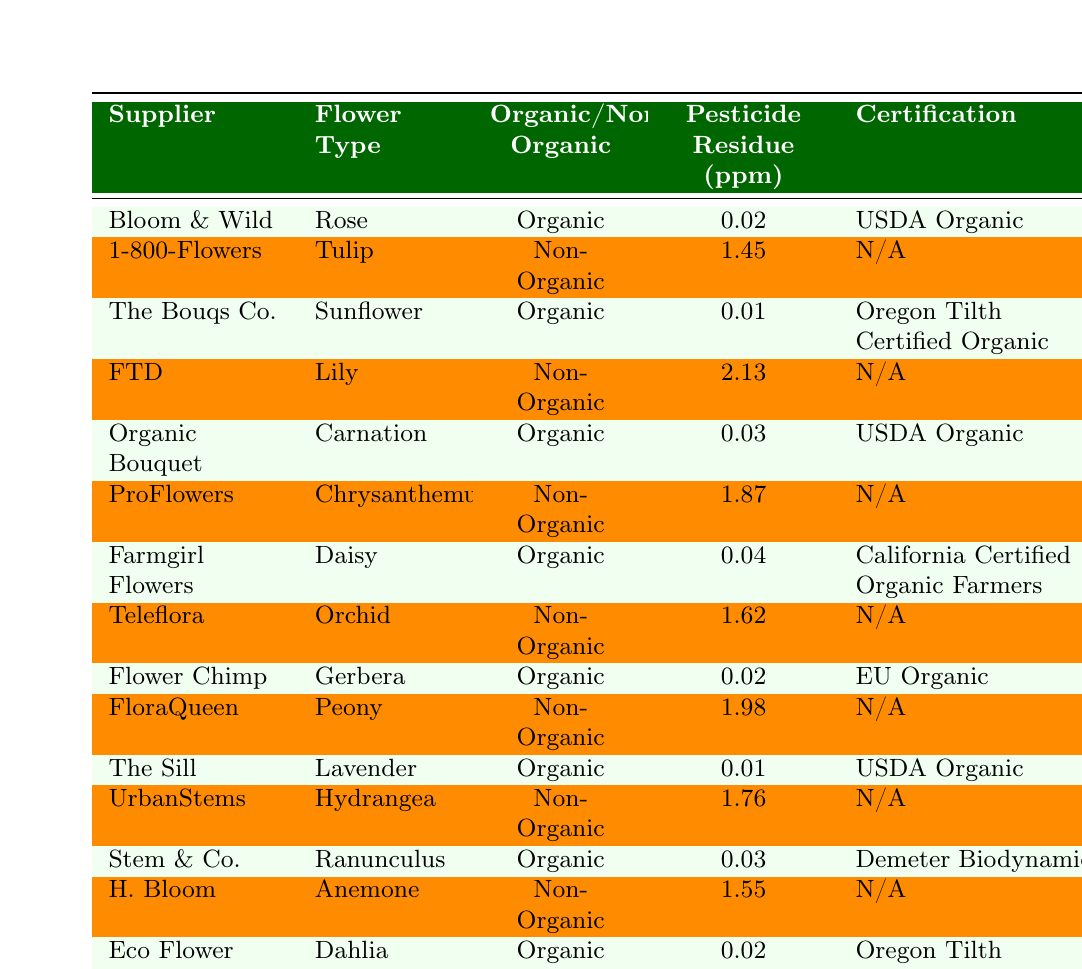What is the pesticide residue level of the Rose from Bloom & Wild? The table shows that the pesticide residue level for the Rose from Bloom & Wild is 0.02 ppm.
Answer: 0.02 ppm Which supplier offers non-organic flowers with the highest pesticide residue? By inspecting the table, FTD offers the non-organic Lily, which has the highest pesticide residue level of 2.13 ppm.
Answer: FTD How many suppliers provide organic flowers? The table lists 7 suppliers that provide organic flowers: Bloom & Wild, The Bouqs Co., Organic Bouquet, Farmgirl Flowers, Flower Chimp, The Sill, Stem & Co., and Eco Flower.
Answer: 7 What is the average pesticide residue level of the organic flowers? The pesticide residue levels for organic flowers are 0.02, 0.01, 0.03, 0.04, 0.02, 0.01, 0.03, and 0.02 ppm. Adding these gives 0.14, and dividing by 8 (the total number of organic flowers) gives an average of 0.0175 ppm.
Answer: 0.0175 ppm Is there a supplier that has both organic and non-organic flowers? By checking the table, we see that both 1-800-Flowers and ProFlowers offer non-organic flowers, and they do not provide organic flowers; however, FTD and Teleflora also do not provide organic flowers. Therefore, no suppliers have both categories listed.
Answer: No Which organic flower has the lowest pesticide residue, and what is its value? The table shows that the Sunflower from The Bouqs Co. has the lowest pesticide residue at 0.01 ppm.
Answer: Sunflower, 0.01 ppm What is the total pesticide residue level of non-organic flowers? The pesticide residue levels for non-organic flowers are 1.45, 2.13, 1.87, 1.62, 1.98, 1.76, and 1.55 ppm. Adding these values together gives 12.36 ppm.
Answer: 12.36 ppm Does the Organic Bouquet have a certification? The table indicates that Organic Bouquet is certified as USDA Organic, confirming it does have a certification.
Answer: Yes Which flower type has a pesticide residue level of exactly 0.02 ppm? From the table data, both the Rose from Bloom & Wild and the Gerbera from Flower Chimp have a pesticide residue level of 0.02 ppm.
Answer: Rose, Gerbera What percentage of the total entries are organic flowers? There are 15 total flower entries, with 8 being organic. To find the percentage, divide 8 by 15 and multiply by 100, resulting in approximately 53.33%.
Answer: 53.33% 